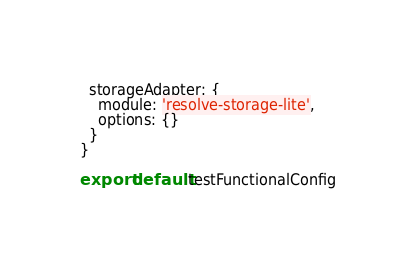Convert code to text. <code><loc_0><loc_0><loc_500><loc_500><_JavaScript_>
  storageAdapter: {
    module: 'resolve-storage-lite',
    options: {}
  }
}

export default testFunctionalConfig
</code> 